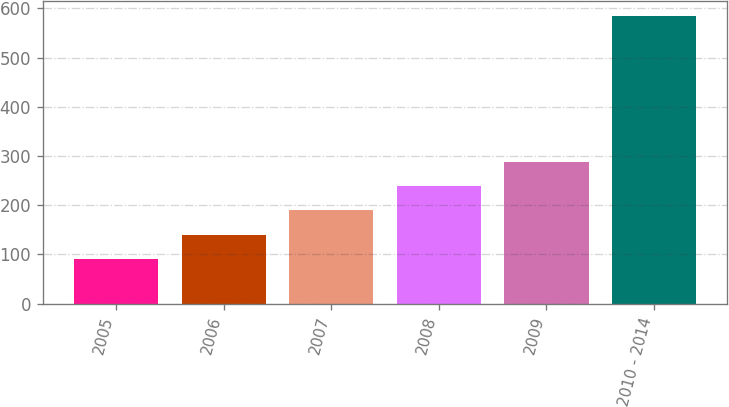Convert chart to OTSL. <chart><loc_0><loc_0><loc_500><loc_500><bar_chart><fcel>2005<fcel>2006<fcel>2007<fcel>2008<fcel>2009<fcel>2010 - 2014<nl><fcel>91<fcel>140.4<fcel>189.8<fcel>239.2<fcel>288.6<fcel>585<nl></chart> 